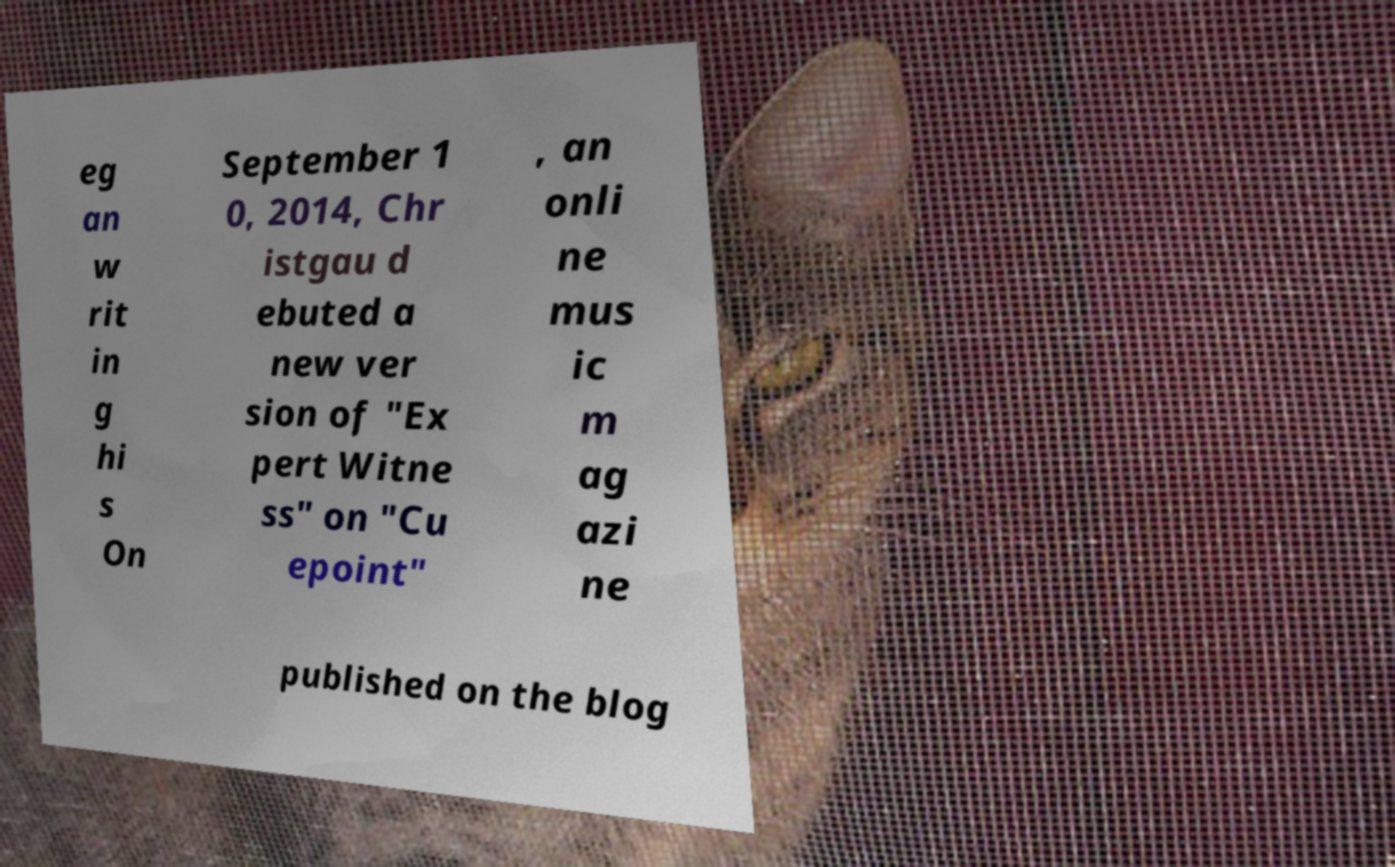There's text embedded in this image that I need extracted. Can you transcribe it verbatim? eg an w rit in g hi s On September 1 0, 2014, Chr istgau d ebuted a new ver sion of "Ex pert Witne ss" on "Cu epoint" , an onli ne mus ic m ag azi ne published on the blog 